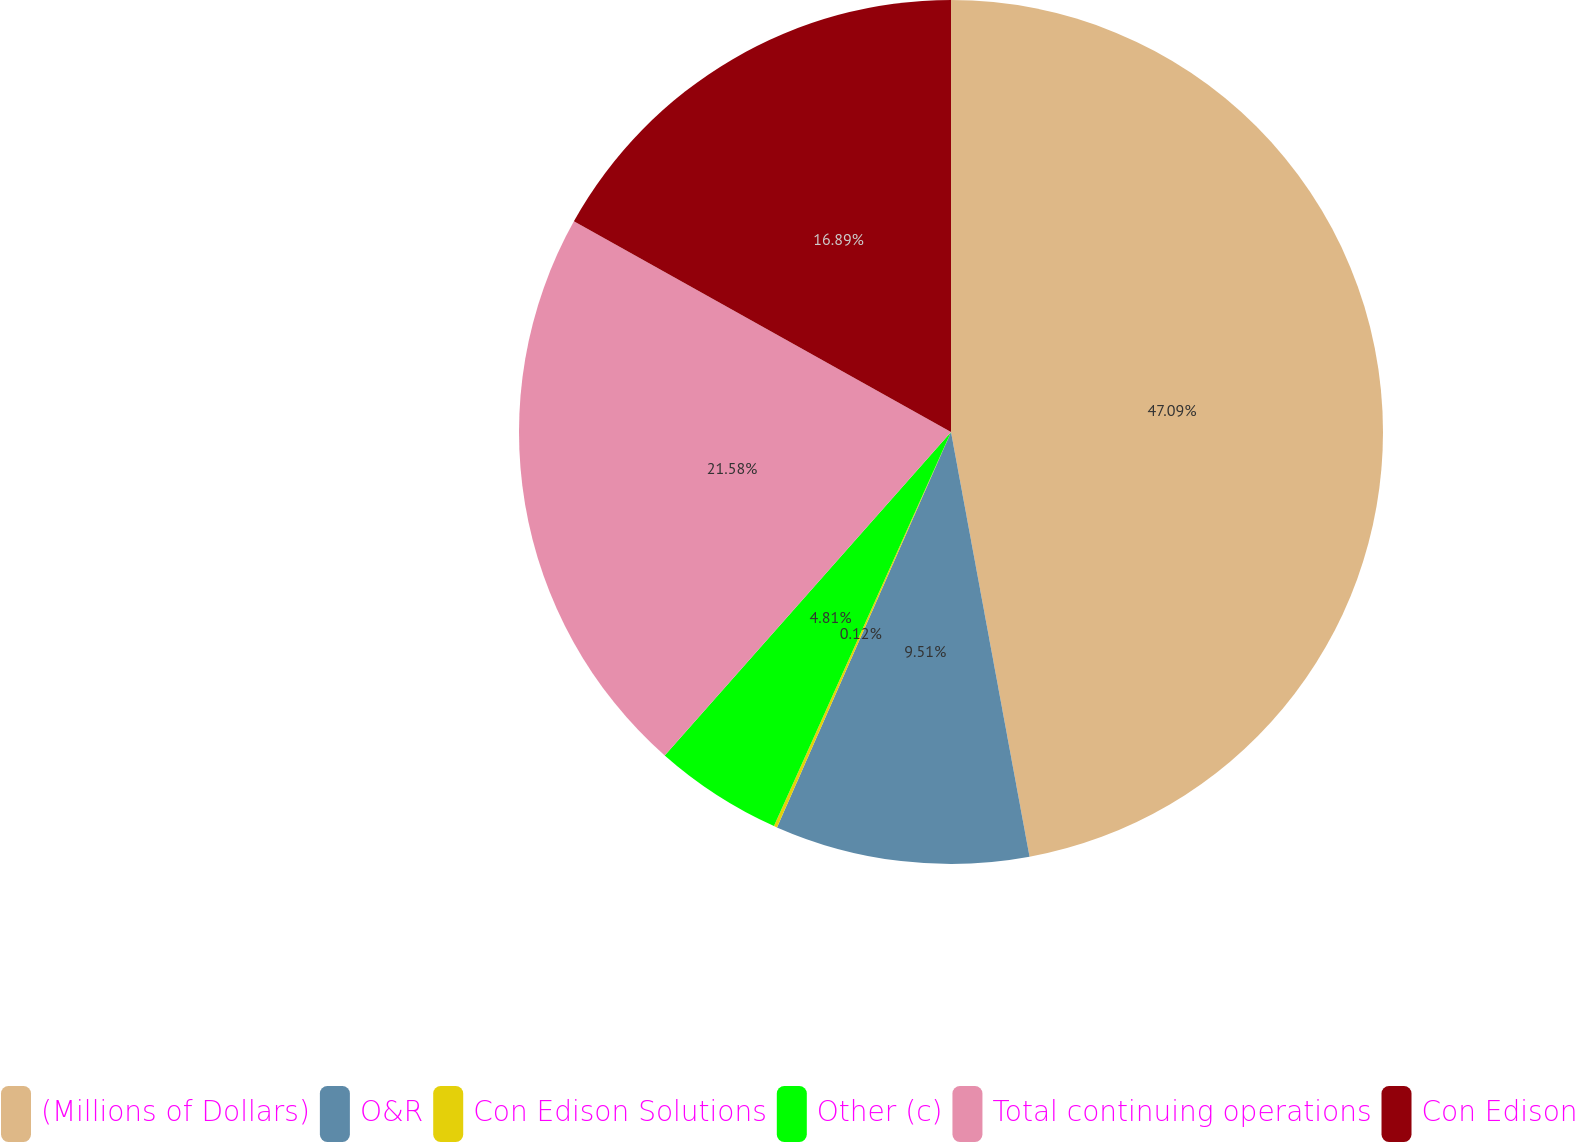<chart> <loc_0><loc_0><loc_500><loc_500><pie_chart><fcel>(Millions of Dollars)<fcel>O&R<fcel>Con Edison Solutions<fcel>Other (c)<fcel>Total continuing operations<fcel>Con Edison<nl><fcel>47.09%<fcel>9.51%<fcel>0.12%<fcel>4.81%<fcel>21.58%<fcel>16.89%<nl></chart> 